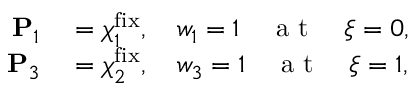<formula> <loc_0><loc_0><loc_500><loc_500>\begin{array} { r l } { P _ { 1 } } & = \boldsymbol \chi _ { 1 } ^ { f i x } , \quad w _ { 1 } = 1 \quad a t \quad \xi = 0 , } \\ { P _ { 3 } } & = \boldsymbol \chi _ { 2 } ^ { f i x } , \quad w _ { 3 } = 1 \quad a t \quad \xi = 1 , } \end{array}</formula> 